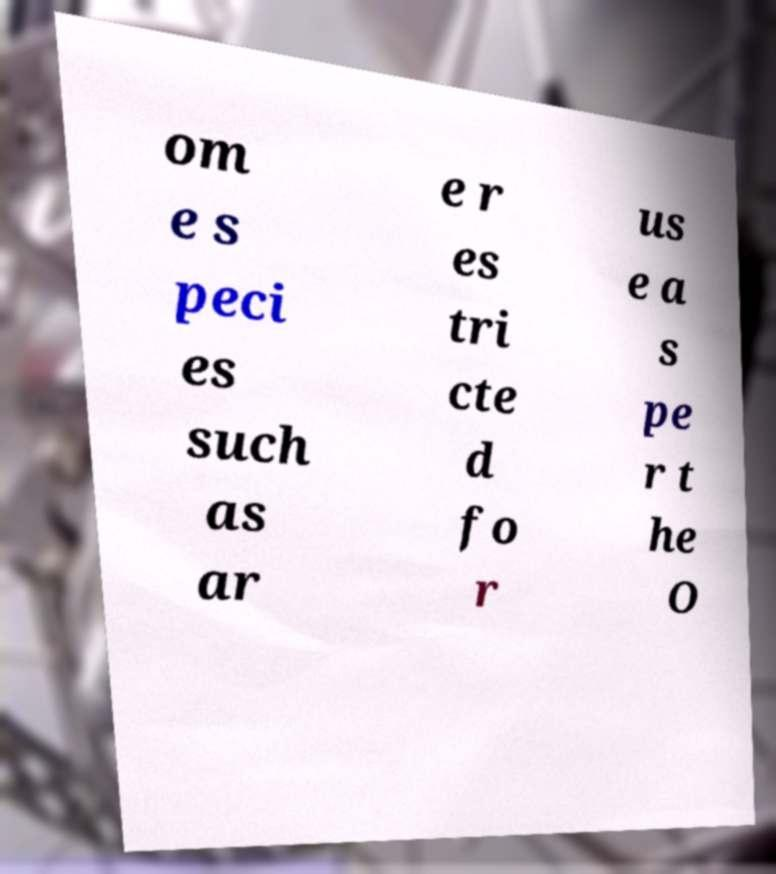What messages or text are displayed in this image? I need them in a readable, typed format. om e s peci es such as ar e r es tri cte d fo r us e a s pe r t he O 